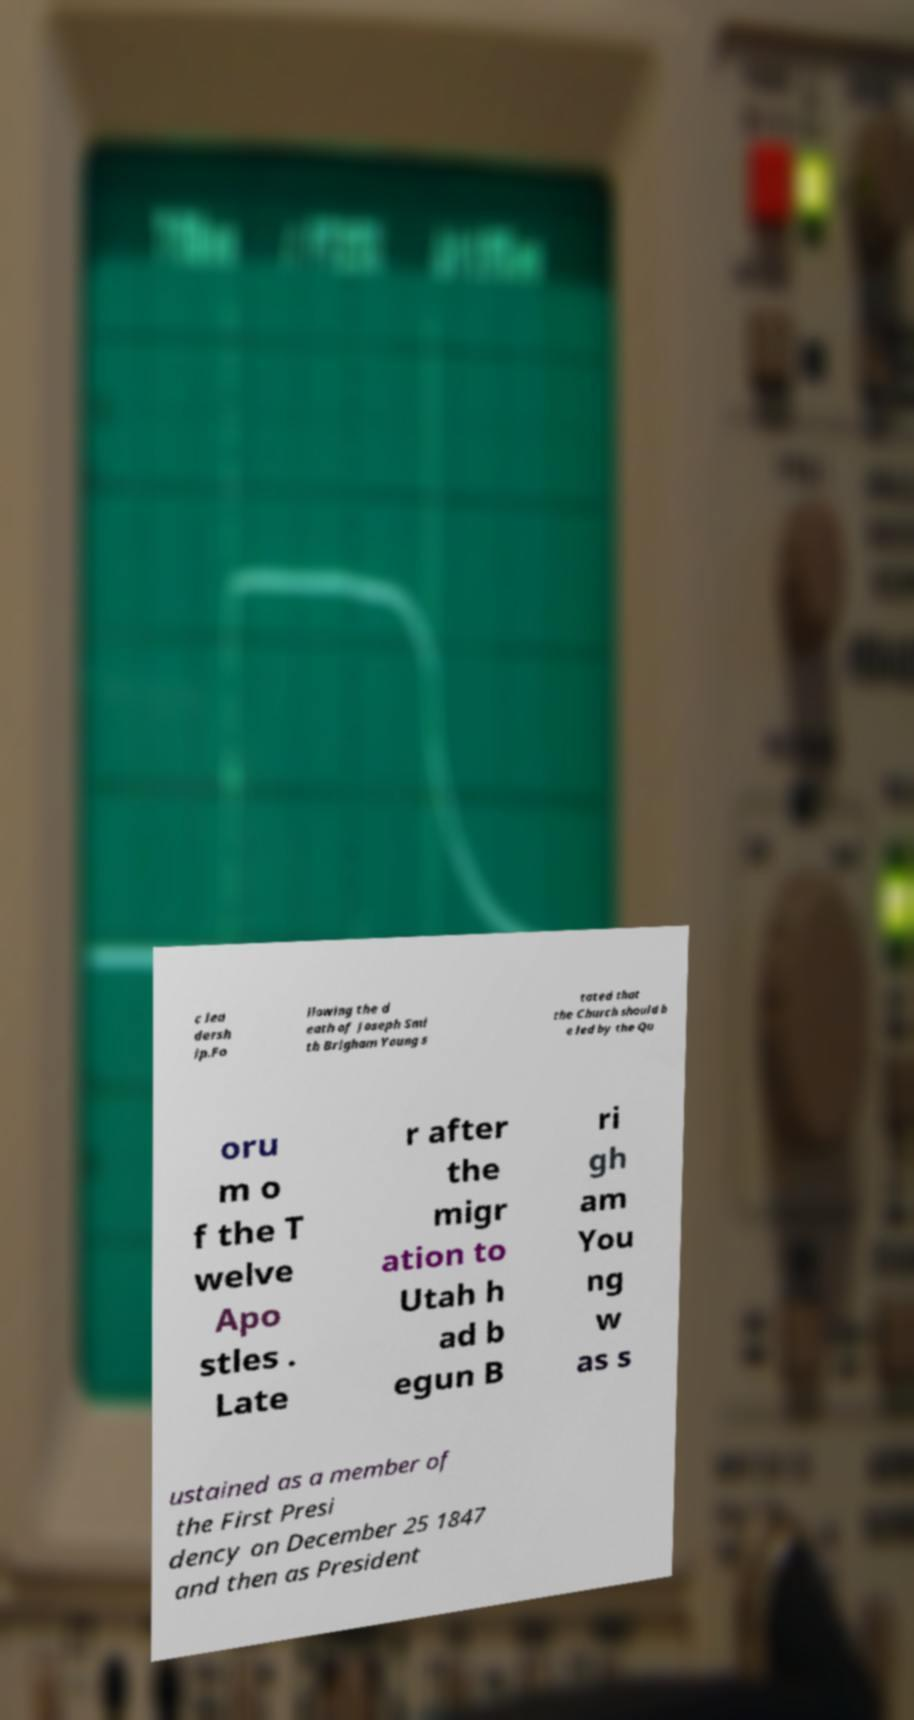What messages or text are displayed in this image? I need them in a readable, typed format. c lea dersh ip.Fo llowing the d eath of Joseph Smi th Brigham Young s tated that the Church should b e led by the Qu oru m o f the T welve Apo stles . Late r after the migr ation to Utah h ad b egun B ri gh am You ng w as s ustained as a member of the First Presi dency on December 25 1847 and then as President 